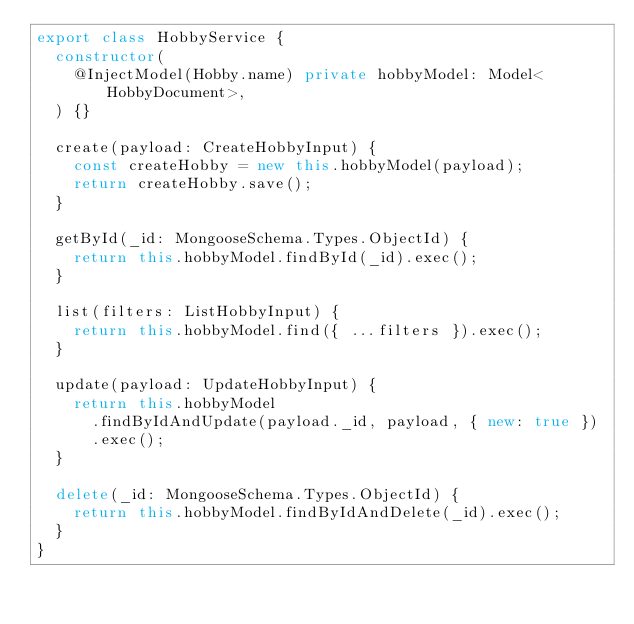<code> <loc_0><loc_0><loc_500><loc_500><_TypeScript_>export class HobbyService {
  constructor(
    @InjectModel(Hobby.name) private hobbyModel: Model<HobbyDocument>,
  ) {}

  create(payload: CreateHobbyInput) {
    const createHobby = new this.hobbyModel(payload);
    return createHobby.save();
  }

  getById(_id: MongooseSchema.Types.ObjectId) {
    return this.hobbyModel.findById(_id).exec();
  }

  list(filters: ListHobbyInput) {
    return this.hobbyModel.find({ ...filters }).exec();
  }

  update(payload: UpdateHobbyInput) {
    return this.hobbyModel
      .findByIdAndUpdate(payload._id, payload, { new: true })
      .exec();
  }

  delete(_id: MongooseSchema.Types.ObjectId) {
    return this.hobbyModel.findByIdAndDelete(_id).exec();
  }
}
</code> 